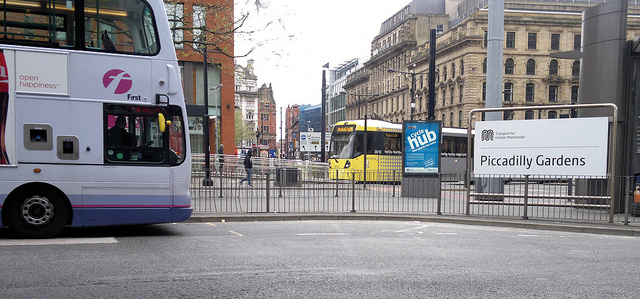What type of day does it appear to be based on the image? The image shows an overcast sky, which suggests it might be a cool or cloudy day. The absence of deep shadows indicates that the sun isn't shining brightly, and the overall lighting is quite even. 